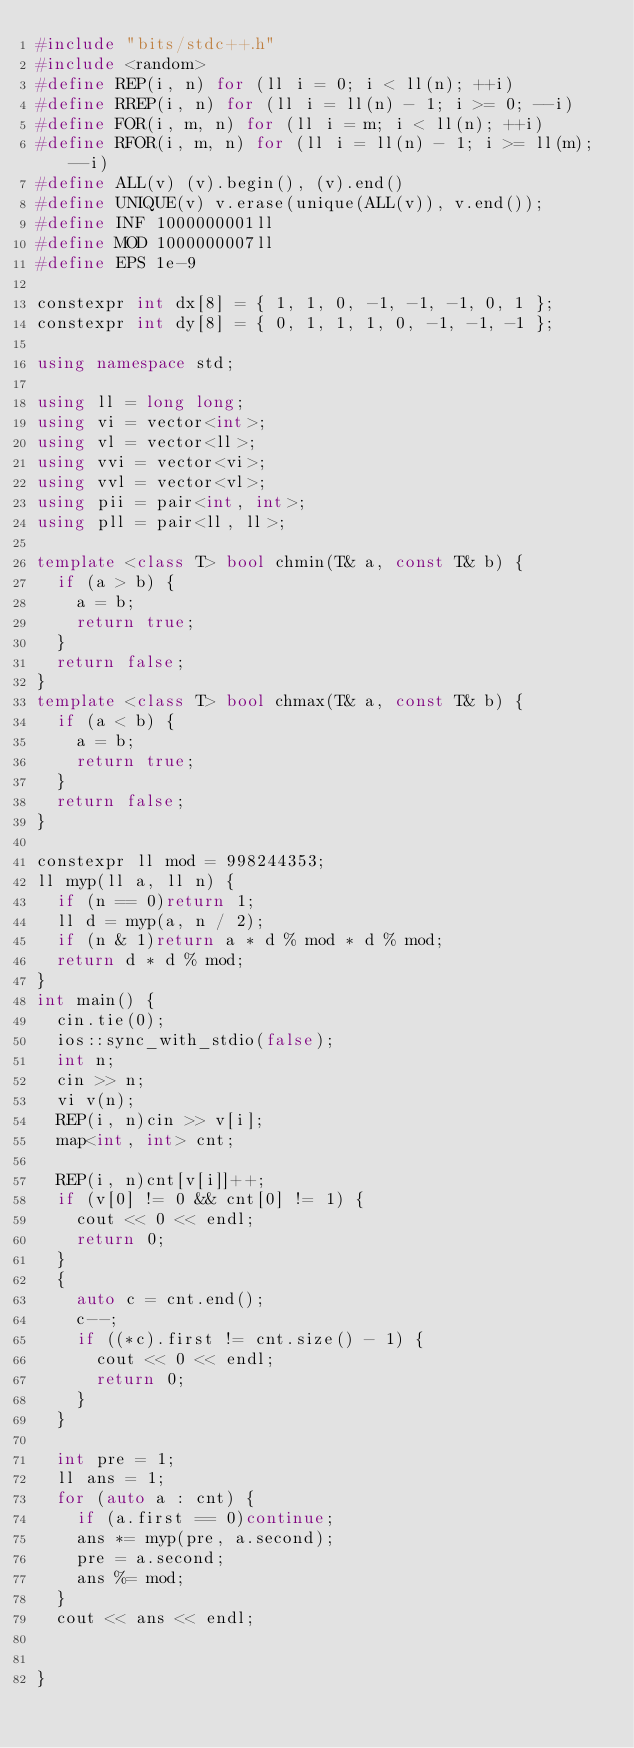Convert code to text. <code><loc_0><loc_0><loc_500><loc_500><_C++_>#include "bits/stdc++.h"
#include <random>
#define REP(i, n) for (ll i = 0; i < ll(n); ++i)
#define RREP(i, n) for (ll i = ll(n) - 1; i >= 0; --i)
#define FOR(i, m, n) for (ll i = m; i < ll(n); ++i)
#define RFOR(i, m, n) for (ll i = ll(n) - 1; i >= ll(m); --i)
#define ALL(v) (v).begin(), (v).end()
#define UNIQUE(v) v.erase(unique(ALL(v)), v.end());
#define INF 1000000001ll
#define MOD 1000000007ll
#define EPS 1e-9

constexpr int dx[8] = { 1, 1, 0, -1, -1, -1, 0, 1 };
constexpr int dy[8] = { 0, 1, 1, 1, 0, -1, -1, -1 };

using namespace std;

using ll = long long;
using vi = vector<int>;
using vl = vector<ll>;
using vvi = vector<vi>;
using vvl = vector<vl>;
using pii = pair<int, int>;
using pll = pair<ll, ll>;

template <class T> bool chmin(T& a, const T& b) {
  if (a > b) {
    a = b;
    return true;
  }
  return false;
}
template <class T> bool chmax(T& a, const T& b) {
  if (a < b) {
    a = b;
    return true;
  }
  return false;
}

constexpr ll mod = 998244353;
ll myp(ll a, ll n) {
  if (n == 0)return 1;
  ll d = myp(a, n / 2);
  if (n & 1)return a * d % mod * d % mod;
  return d * d % mod;
}
int main() {
  cin.tie(0);
  ios::sync_with_stdio(false);
  int n;
  cin >> n;
  vi v(n);
  REP(i, n)cin >> v[i];
  map<int, int> cnt;

  REP(i, n)cnt[v[i]]++;
  if (v[0] != 0 && cnt[0] != 1) {
    cout << 0 << endl;
    return 0;
  }
  {
    auto c = cnt.end();
    c--;
    if ((*c).first != cnt.size() - 1) {
      cout << 0 << endl;
      return 0;
    }
  }
  
  int pre = 1;
  ll ans = 1;
  for (auto a : cnt) {
    if (a.first == 0)continue;
    ans *= myp(pre, a.second);
    pre = a.second;
    ans %= mod;
  }
  cout << ans << endl;
  

}
</code> 